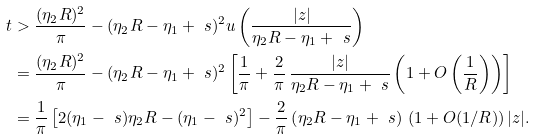<formula> <loc_0><loc_0><loc_500><loc_500>t & > \frac { ( \eta _ { 2 } R ) ^ { 2 } } { \pi } - ( \eta _ { 2 } R - \eta _ { 1 } + \ s ) ^ { 2 } u \left ( \frac { | z | } { \eta _ { 2 } R - \eta _ { 1 } + \ s } \right ) \\ & = \frac { ( \eta _ { 2 } R ) ^ { 2 } } { \pi } - ( \eta _ { 2 } R - \eta _ { 1 } + \ s ) ^ { 2 } \left [ \frac { 1 } { \pi } + \frac { 2 } { \pi } \, \frac { | z | } { \eta _ { 2 } R - \eta _ { 1 } + \ s } \left ( 1 + O \left ( \frac { 1 } { R } \right ) \right ) \right ] \\ & = \frac { 1 } { \pi } \left [ 2 ( \eta _ { 1 } - \ s ) \eta _ { 2 } R - ( \eta _ { 1 } - \ s ) ^ { 2 } \right ] - \frac { 2 } { \pi } \left ( \eta _ { 2 } R - \eta _ { 1 } + \ s \right ) \, ( 1 + O ( 1 / R ) ) \, | z | .</formula> 